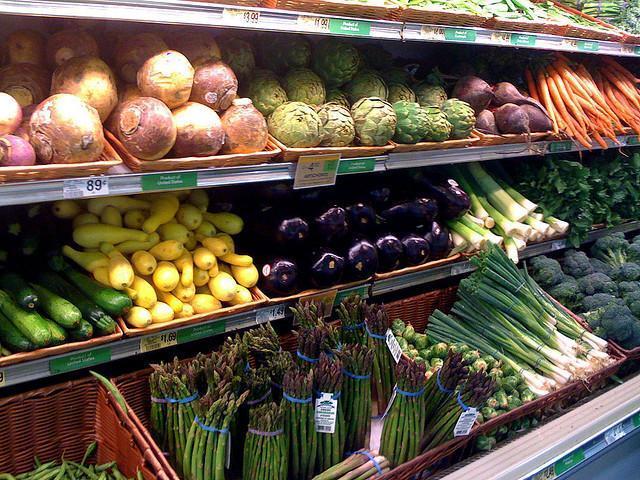How many people are in the image?
Give a very brief answer. 0. 